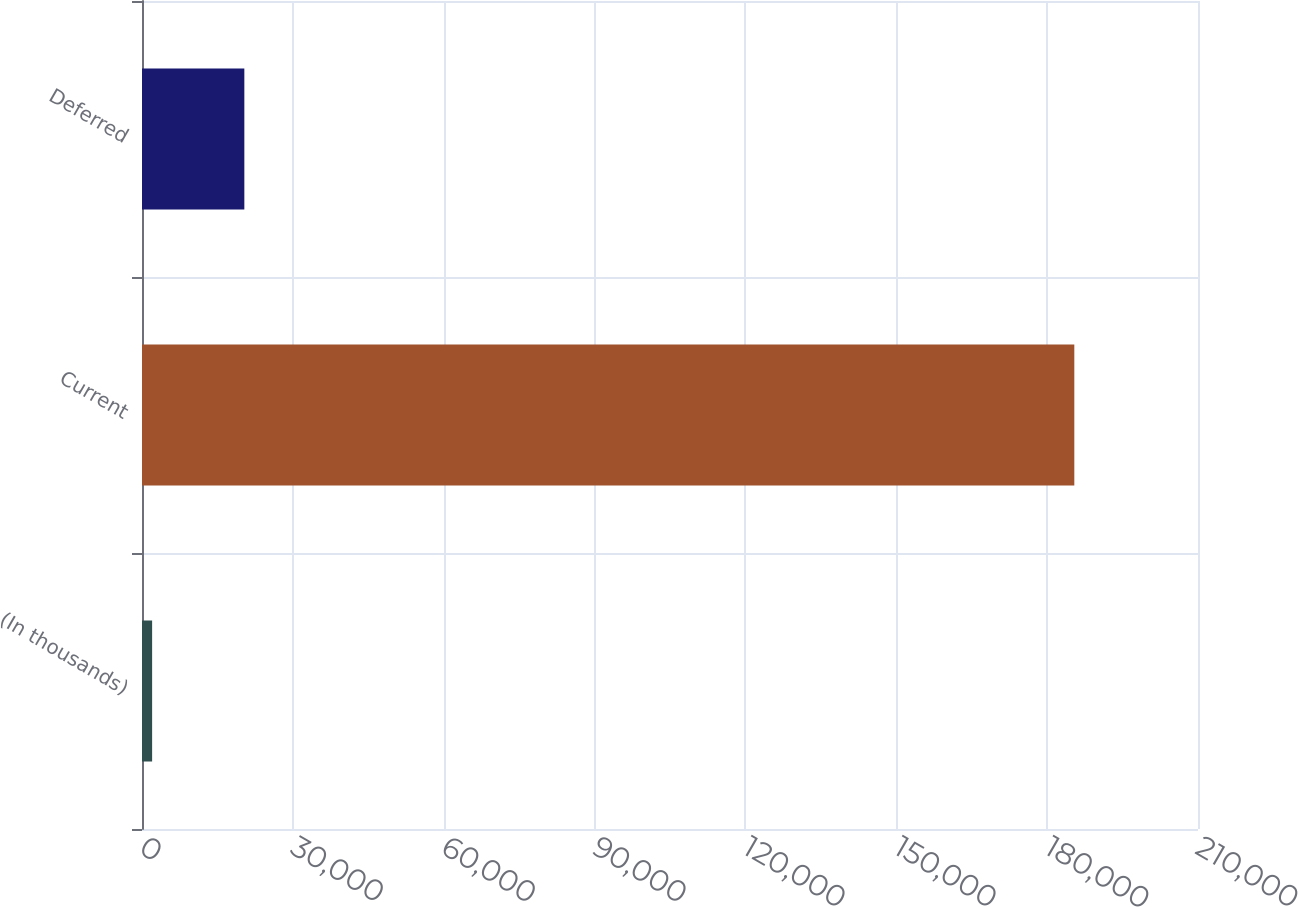Convert chart. <chart><loc_0><loc_0><loc_500><loc_500><bar_chart><fcel>(In thousands)<fcel>Current<fcel>Deferred<nl><fcel>2012<fcel>185404<fcel>20351.2<nl></chart> 